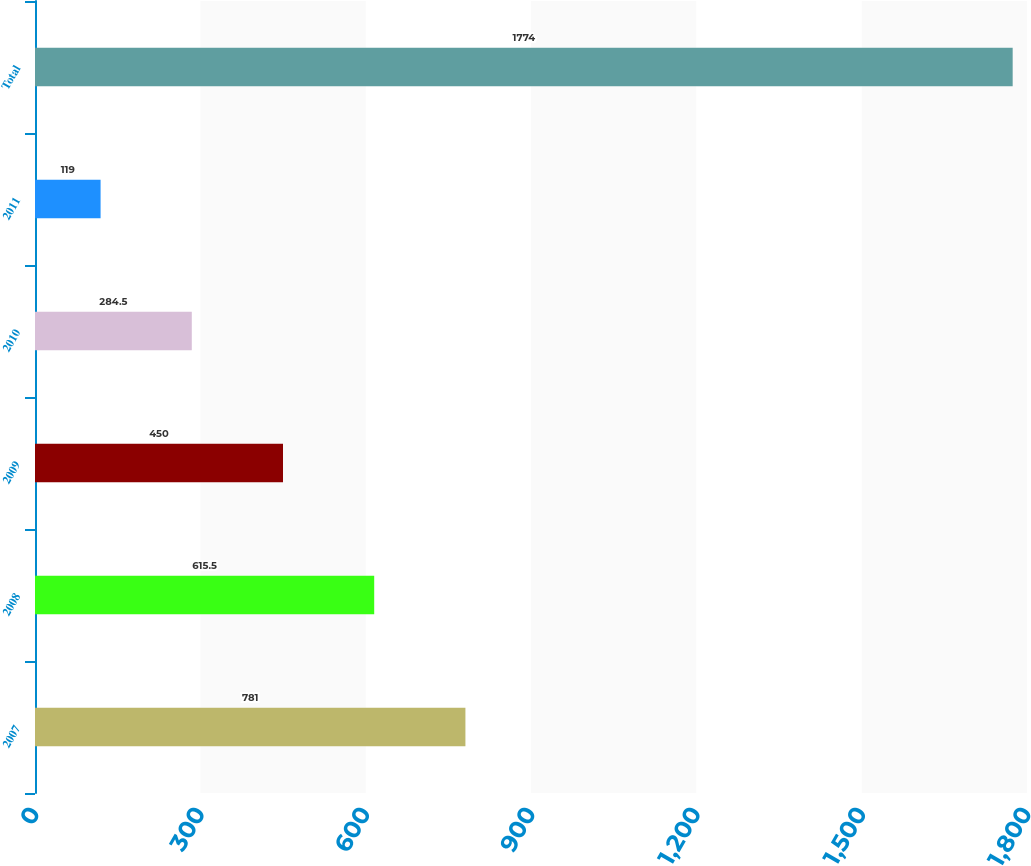Convert chart. <chart><loc_0><loc_0><loc_500><loc_500><bar_chart><fcel>2007<fcel>2008<fcel>2009<fcel>2010<fcel>2011<fcel>Total<nl><fcel>781<fcel>615.5<fcel>450<fcel>284.5<fcel>119<fcel>1774<nl></chart> 